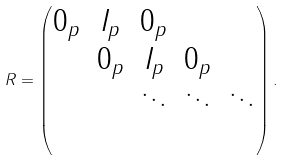Convert formula to latex. <formula><loc_0><loc_0><loc_500><loc_500>R = \begin{pmatrix} 0 _ { p } & I _ { p } & 0 _ { p } & & \\ & 0 _ { p } & I _ { p } & 0 _ { p } & \\ & & \ddots & \ddots & \ddots \\ & & & & \\ \end{pmatrix} .</formula> 